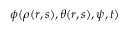Convert formula to latex. <formula><loc_0><loc_0><loc_500><loc_500>\phi ( \rho ( r , s ) , \theta ( r , s ) , \psi , t )</formula> 